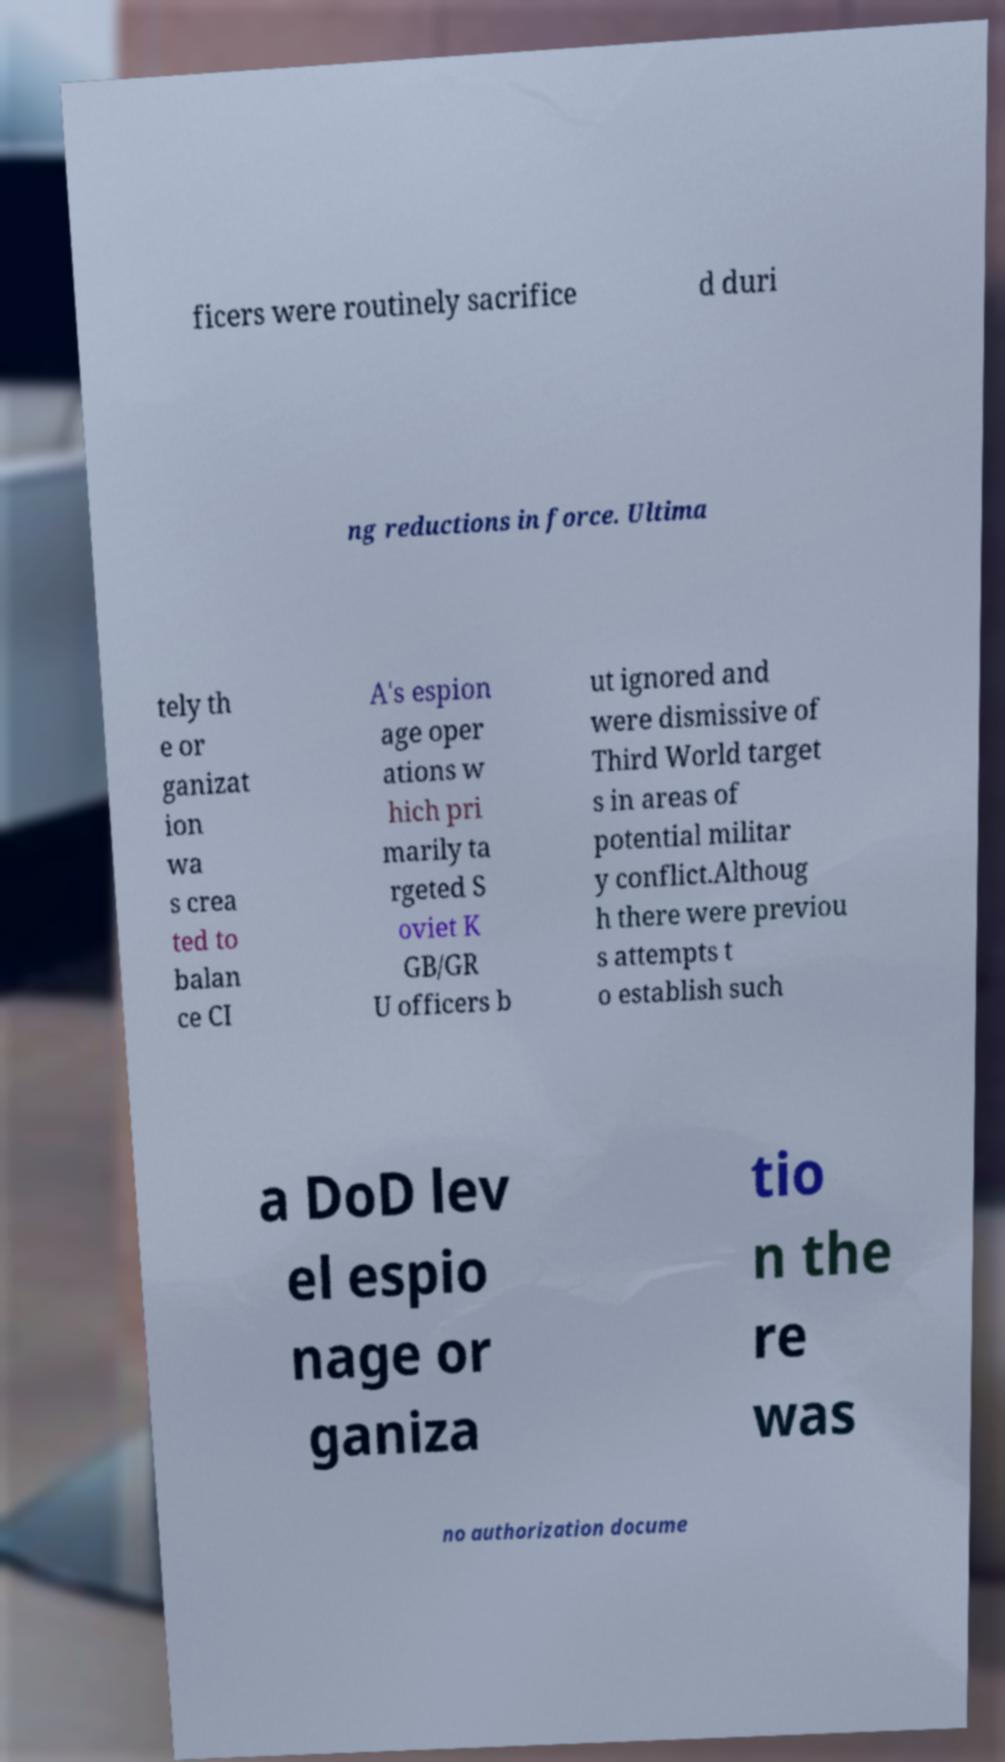Can you accurately transcribe the text from the provided image for me? ficers were routinely sacrifice d duri ng reductions in force. Ultima tely th e or ganizat ion wa s crea ted to balan ce CI A's espion age oper ations w hich pri marily ta rgeted S oviet K GB/GR U officers b ut ignored and were dismissive of Third World target s in areas of potential militar y conflict.Althoug h there were previou s attempts t o establish such a DoD lev el espio nage or ganiza tio n the re was no authorization docume 